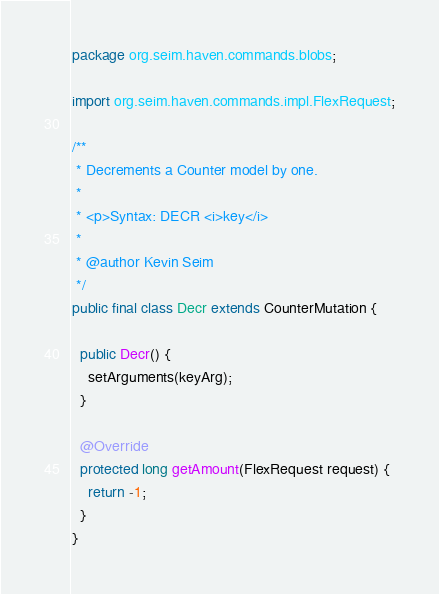Convert code to text. <code><loc_0><loc_0><loc_500><loc_500><_Java_>package org.seim.haven.commands.blobs;

import org.seim.haven.commands.impl.FlexRequest;

/**
 * Decrements a Counter model by one.
 * 
 * <p>Syntax: DECR <i>key</i>
 * 
 * @author Kevin Seim
 */
public final class Decr extends CounterMutation {

  public Decr() {
    setArguments(keyArg);
  }

  @Override
  protected long getAmount(FlexRequest request) {
    return -1;
  }
}
</code> 